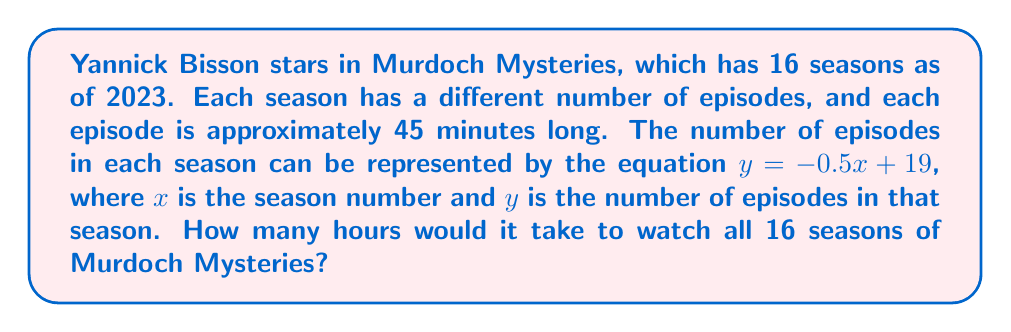Can you answer this question? Let's approach this problem step by step:

1) First, we need to find the total number of episodes across all 16 seasons. We can do this by summing the number of episodes for each season.

2) The number of episodes in each season is given by the equation:
   $y = -0.5x + 19$, where $x$ is the season number

3) We need to sum this for $x$ from 1 to 16:

   $$\sum_{x=1}^{16} (-0.5x + 19)$$

4) This sum can be simplified:

   $$19 * 16 - 0.5 * \sum_{x=1}^{16} x$$

5) We know that $\sum_{x=1}^{n} x = \frac{n(n+1)}{2}$

6) So our sum becomes:

   $$19 * 16 - 0.5 * \frac{16(16+1)}{2} = 304 - 68 = 236$$

7) Therefore, there are 236 episodes in total.

8) Each episode is 45 minutes long. To find the total time in minutes:

   $$236 * 45 = 10,620 \text{ minutes}$$

9) To convert this to hours, we divide by 60:

   $$10,620 \div 60 = 177 \text{ hours}$$
Answer: It would take 177 hours to watch all 16 seasons of Murdoch Mysteries. 